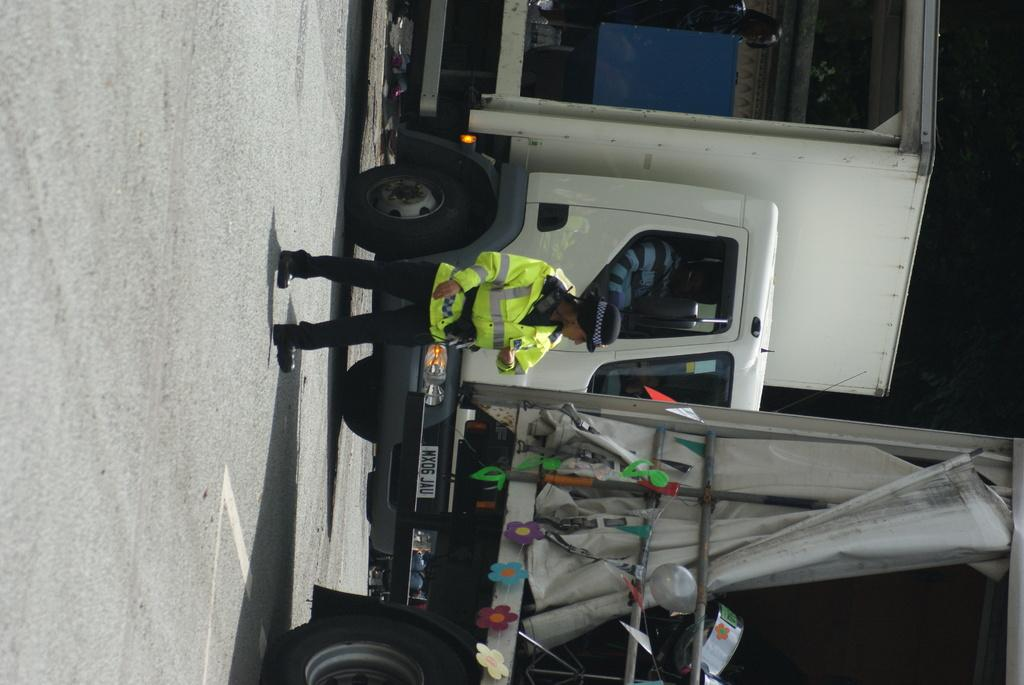What can be seen on the road in the image? There are vehicles on the road in the image. Are there any people visible on the road? Yes, there is a person on the road in the image. What else can be seen in the image besides vehicles and people? There is a balloon and a cloth visible in the image. What is the weight of the honey in the image? There is no honey present in the image, so it is not possible to determine its weight. How does the person on the road plan to join the vehicles? The image does not provide information about the person's intentions or actions, so it is not possible to determine how they plan to join the vehicles. 